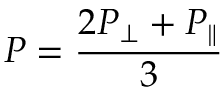<formula> <loc_0><loc_0><loc_500><loc_500>P = \frac { 2 P _ { \perp } + P _ { \| } } { 3 }</formula> 